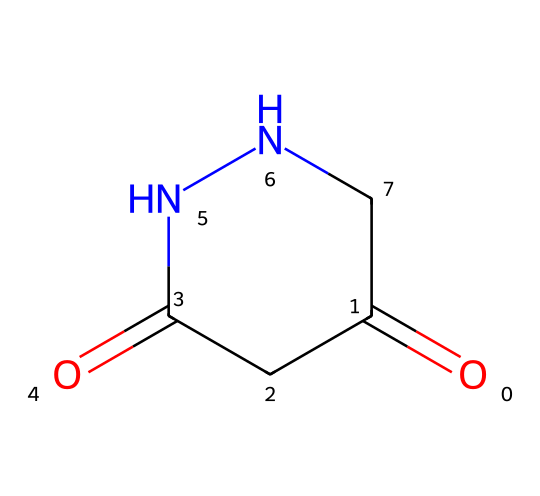What is the molecular formula of maleic hydrazide? By analyzing the SMILES notation, we can determine the atoms present in the molecule. The molecules consist of 4 carbon (C), 6 hydrogen (H), 2 nitrogen (N), and 2 oxygen (O) atoms. Therefore, the molecular formula can be constructed as C4H6N2O2.
Answer: C4H6N2O2 How many nitrogen atoms are present in maleic hydrazide? The SMILES representation indicates that there are two nitrogen (N) atoms in the ring structure, clearly showing them connected to other components of the molecule.
Answer: 2 What type of functional groups are present in maleic hydrazide? The SMILES shows carbonyl groups (C=O) as well as an amine group (attached to nitrogen), indicating the presence of a hydrazine functional group as well.
Answer: carbonyl and hydrazine What is the degree of unsaturation in maleic hydrazide? The degree of unsaturation can be calculated using the formula: (2C + 2 + N - H - X)/2. Substituting C=4, N=2, H=6, yields: (2(4) + 2 + 2 - 6)/2 = 4. This indicates there are four degrees of unsaturation, likely due to two double bonds in the carbonyl groups and two ring structures.
Answer: 4 What structural feature indicates maleic hydrazide is a plant growth regulator? The amine group and the carbonyl moiety often signal plant growth regulation properties, as they are common in many plant growth regulators and herbicides. This chemical's structural configuration supports its bioactivity in plants.
Answer: amine group and carbonyl moiety What cycle is present in the structure of maleic hydrazide? The structure indicates a five-membered ring, characterized by the arrangement of carbon and nitrogen atoms, which is a typical feature in hydrazine-derived compounds. This cyclic structure contributes to its stability and function.
Answer: five-membered ring What is the significance of the carbonyl group in maleic hydrazide's structure? The carbonyl group (C=O) in the structure contributes to reactivity and molecular recognition, playing a crucial role in its biological activity as a growth regulator by participating in various chemical reactions pertinent to plants.
Answer: reactivity and biological activity 